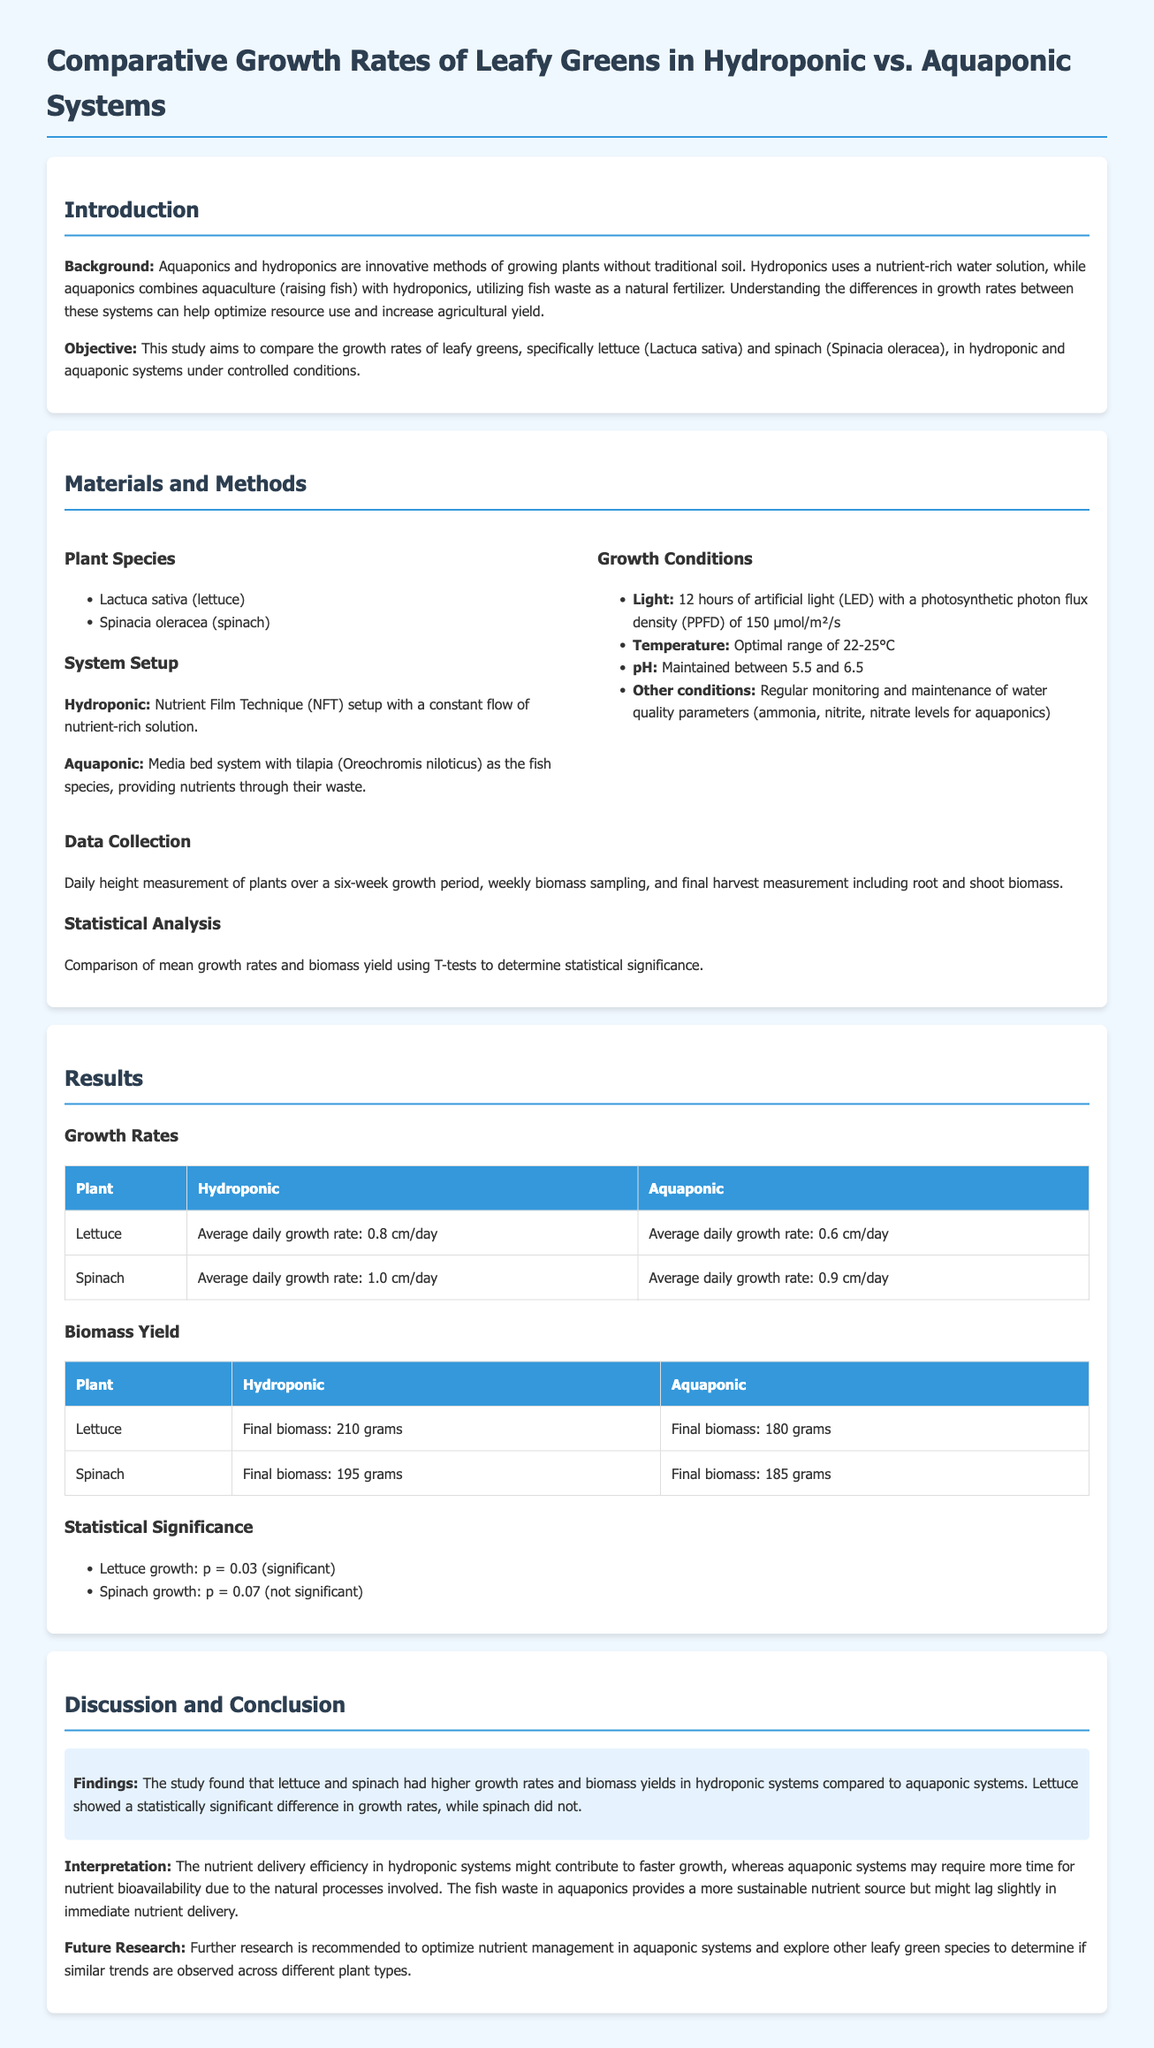what are the two plant species studied? The document lists the two plant species as Lactuca sativa (lettuce) and Spinacia oleracea (spinach).
Answer: Lactuca sativa, Spinacia oleracea what is the average daily growth rate of spinach in hydroponic systems? The average daily growth rate of spinach in hydroponic systems is specified in the results section of the document.
Answer: 1.0 cm/day what was the final biomass of lettuce grown in aquaponic systems? The final biomass of lettuce in aquaponic systems is mentioned in the biomass yield table of the results.
Answer: 180 grams what statistical test was used to determine significance in the study? The document states the statistical test used for analysis was T-tests to determine statistical significance.
Answer: T-tests how many hours of artificial light were provided during the experiment? The provided light conditions detail that there were 12 hours of artificial light given to the plants.
Answer: 12 hours what was the p-value for lettuce growth indicating significance? The p-value for lettuce growth is recorded in the statistical significance section of the results.
Answer: 0.03 which system showed higher biomass yield for spinach? The document describes the results comparing hydroponic and aquaponic systems for biomass yield of spinach.
Answer: Hydroponic what is one recommendation for future research mentioned in the document? The document suggests exploring other leafy green species as a recommendation for future research.
Answer: Other leafy green species 